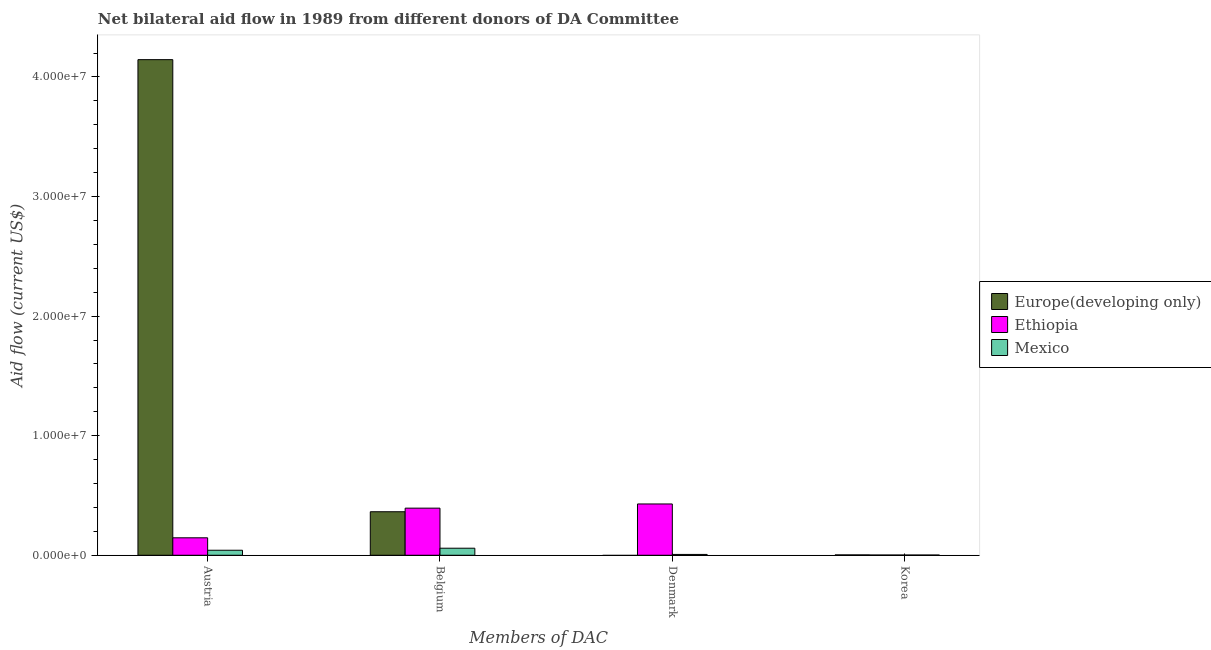How many different coloured bars are there?
Your answer should be compact. 3. How many groups of bars are there?
Make the answer very short. 4. Are the number of bars on each tick of the X-axis equal?
Make the answer very short. No. How many bars are there on the 1st tick from the right?
Keep it short and to the point. 3. What is the label of the 1st group of bars from the left?
Your response must be concise. Austria. Across all countries, what is the maximum amount of aid given by korea?
Ensure brevity in your answer.  3.00e+04. Across all countries, what is the minimum amount of aid given by belgium?
Your answer should be very brief. 5.90e+05. In which country was the amount of aid given by belgium maximum?
Keep it short and to the point. Ethiopia. What is the total amount of aid given by korea in the graph?
Your answer should be compact. 7.00e+04. What is the difference between the amount of aid given by austria in Ethiopia and that in Mexico?
Ensure brevity in your answer.  1.04e+06. What is the difference between the amount of aid given by austria in Mexico and the amount of aid given by denmark in Ethiopia?
Your response must be concise. -3.87e+06. What is the average amount of aid given by belgium per country?
Provide a short and direct response. 2.72e+06. What is the difference between the amount of aid given by austria and amount of aid given by belgium in Mexico?
Make the answer very short. -1.70e+05. In how many countries, is the amount of aid given by austria greater than 36000000 US$?
Your answer should be very brief. 1. What is the ratio of the amount of aid given by belgium in Ethiopia to that in Europe(developing only)?
Offer a terse response. 1.08. Is the amount of aid given by belgium in Mexico less than that in Ethiopia?
Your answer should be compact. Yes. Is the difference between the amount of aid given by korea in Mexico and Ethiopia greater than the difference between the amount of aid given by austria in Mexico and Ethiopia?
Your answer should be compact. Yes. What is the difference between the highest and the lowest amount of aid given by denmark?
Provide a succinct answer. 4.29e+06. In how many countries, is the amount of aid given by austria greater than the average amount of aid given by austria taken over all countries?
Your answer should be very brief. 1. Is it the case that in every country, the sum of the amount of aid given by austria and amount of aid given by korea is greater than the sum of amount of aid given by belgium and amount of aid given by denmark?
Offer a terse response. No. Is it the case that in every country, the sum of the amount of aid given by austria and amount of aid given by belgium is greater than the amount of aid given by denmark?
Offer a terse response. Yes. Are all the bars in the graph horizontal?
Keep it short and to the point. No. What is the difference between two consecutive major ticks on the Y-axis?
Provide a succinct answer. 1.00e+07. Does the graph contain any zero values?
Provide a succinct answer. Yes. Does the graph contain grids?
Your answer should be very brief. No. Where does the legend appear in the graph?
Provide a short and direct response. Center right. How are the legend labels stacked?
Your response must be concise. Vertical. What is the title of the graph?
Keep it short and to the point. Net bilateral aid flow in 1989 from different donors of DA Committee. Does "Greece" appear as one of the legend labels in the graph?
Keep it short and to the point. No. What is the label or title of the X-axis?
Give a very brief answer. Members of DAC. What is the label or title of the Y-axis?
Your answer should be very brief. Aid flow (current US$). What is the Aid flow (current US$) in Europe(developing only) in Austria?
Provide a succinct answer. 4.14e+07. What is the Aid flow (current US$) in Ethiopia in Austria?
Your response must be concise. 1.46e+06. What is the Aid flow (current US$) in Europe(developing only) in Belgium?
Your response must be concise. 3.64e+06. What is the Aid flow (current US$) of Ethiopia in Belgium?
Give a very brief answer. 3.94e+06. What is the Aid flow (current US$) of Mexico in Belgium?
Your answer should be very brief. 5.90e+05. What is the Aid flow (current US$) in Ethiopia in Denmark?
Provide a succinct answer. 4.29e+06. What is the Aid flow (current US$) of Mexico in Denmark?
Keep it short and to the point. 7.00e+04. What is the Aid flow (current US$) in Ethiopia in Korea?
Make the answer very short. 2.00e+04. Across all Members of DAC, what is the maximum Aid flow (current US$) in Europe(developing only)?
Offer a terse response. 4.14e+07. Across all Members of DAC, what is the maximum Aid flow (current US$) in Ethiopia?
Provide a succinct answer. 4.29e+06. Across all Members of DAC, what is the maximum Aid flow (current US$) of Mexico?
Your answer should be very brief. 5.90e+05. Across all Members of DAC, what is the minimum Aid flow (current US$) of Europe(developing only)?
Make the answer very short. 0. What is the total Aid flow (current US$) in Europe(developing only) in the graph?
Make the answer very short. 4.51e+07. What is the total Aid flow (current US$) in Ethiopia in the graph?
Give a very brief answer. 9.71e+06. What is the total Aid flow (current US$) of Mexico in the graph?
Provide a short and direct response. 1.10e+06. What is the difference between the Aid flow (current US$) of Europe(developing only) in Austria and that in Belgium?
Your response must be concise. 3.78e+07. What is the difference between the Aid flow (current US$) in Ethiopia in Austria and that in Belgium?
Your answer should be very brief. -2.48e+06. What is the difference between the Aid flow (current US$) of Mexico in Austria and that in Belgium?
Make the answer very short. -1.70e+05. What is the difference between the Aid flow (current US$) of Ethiopia in Austria and that in Denmark?
Ensure brevity in your answer.  -2.83e+06. What is the difference between the Aid flow (current US$) in Mexico in Austria and that in Denmark?
Ensure brevity in your answer.  3.50e+05. What is the difference between the Aid flow (current US$) of Europe(developing only) in Austria and that in Korea?
Provide a succinct answer. 4.14e+07. What is the difference between the Aid flow (current US$) of Ethiopia in Austria and that in Korea?
Your answer should be very brief. 1.44e+06. What is the difference between the Aid flow (current US$) of Ethiopia in Belgium and that in Denmark?
Your answer should be very brief. -3.50e+05. What is the difference between the Aid flow (current US$) in Mexico in Belgium and that in Denmark?
Keep it short and to the point. 5.20e+05. What is the difference between the Aid flow (current US$) of Europe(developing only) in Belgium and that in Korea?
Provide a short and direct response. 3.61e+06. What is the difference between the Aid flow (current US$) in Ethiopia in Belgium and that in Korea?
Your answer should be compact. 3.92e+06. What is the difference between the Aid flow (current US$) of Mexico in Belgium and that in Korea?
Your response must be concise. 5.70e+05. What is the difference between the Aid flow (current US$) of Ethiopia in Denmark and that in Korea?
Keep it short and to the point. 4.27e+06. What is the difference between the Aid flow (current US$) of Europe(developing only) in Austria and the Aid flow (current US$) of Ethiopia in Belgium?
Your response must be concise. 3.75e+07. What is the difference between the Aid flow (current US$) in Europe(developing only) in Austria and the Aid flow (current US$) in Mexico in Belgium?
Your answer should be very brief. 4.09e+07. What is the difference between the Aid flow (current US$) in Ethiopia in Austria and the Aid flow (current US$) in Mexico in Belgium?
Provide a succinct answer. 8.70e+05. What is the difference between the Aid flow (current US$) in Europe(developing only) in Austria and the Aid flow (current US$) in Ethiopia in Denmark?
Make the answer very short. 3.72e+07. What is the difference between the Aid flow (current US$) of Europe(developing only) in Austria and the Aid flow (current US$) of Mexico in Denmark?
Ensure brevity in your answer.  4.14e+07. What is the difference between the Aid flow (current US$) of Ethiopia in Austria and the Aid flow (current US$) of Mexico in Denmark?
Your answer should be compact. 1.39e+06. What is the difference between the Aid flow (current US$) of Europe(developing only) in Austria and the Aid flow (current US$) of Ethiopia in Korea?
Your response must be concise. 4.14e+07. What is the difference between the Aid flow (current US$) of Europe(developing only) in Austria and the Aid flow (current US$) of Mexico in Korea?
Give a very brief answer. 4.14e+07. What is the difference between the Aid flow (current US$) in Ethiopia in Austria and the Aid flow (current US$) in Mexico in Korea?
Keep it short and to the point. 1.44e+06. What is the difference between the Aid flow (current US$) in Europe(developing only) in Belgium and the Aid flow (current US$) in Ethiopia in Denmark?
Your answer should be very brief. -6.50e+05. What is the difference between the Aid flow (current US$) of Europe(developing only) in Belgium and the Aid flow (current US$) of Mexico in Denmark?
Your answer should be compact. 3.57e+06. What is the difference between the Aid flow (current US$) of Ethiopia in Belgium and the Aid flow (current US$) of Mexico in Denmark?
Give a very brief answer. 3.87e+06. What is the difference between the Aid flow (current US$) in Europe(developing only) in Belgium and the Aid flow (current US$) in Ethiopia in Korea?
Your answer should be compact. 3.62e+06. What is the difference between the Aid flow (current US$) in Europe(developing only) in Belgium and the Aid flow (current US$) in Mexico in Korea?
Make the answer very short. 3.62e+06. What is the difference between the Aid flow (current US$) in Ethiopia in Belgium and the Aid flow (current US$) in Mexico in Korea?
Offer a very short reply. 3.92e+06. What is the difference between the Aid flow (current US$) of Ethiopia in Denmark and the Aid flow (current US$) of Mexico in Korea?
Provide a succinct answer. 4.27e+06. What is the average Aid flow (current US$) of Europe(developing only) per Members of DAC?
Provide a short and direct response. 1.13e+07. What is the average Aid flow (current US$) of Ethiopia per Members of DAC?
Your answer should be very brief. 2.43e+06. What is the average Aid flow (current US$) in Mexico per Members of DAC?
Provide a succinct answer. 2.75e+05. What is the difference between the Aid flow (current US$) of Europe(developing only) and Aid flow (current US$) of Ethiopia in Austria?
Make the answer very short. 4.00e+07. What is the difference between the Aid flow (current US$) of Europe(developing only) and Aid flow (current US$) of Mexico in Austria?
Your answer should be very brief. 4.10e+07. What is the difference between the Aid flow (current US$) of Ethiopia and Aid flow (current US$) of Mexico in Austria?
Your response must be concise. 1.04e+06. What is the difference between the Aid flow (current US$) in Europe(developing only) and Aid flow (current US$) in Mexico in Belgium?
Keep it short and to the point. 3.05e+06. What is the difference between the Aid flow (current US$) in Ethiopia and Aid flow (current US$) in Mexico in Belgium?
Provide a succinct answer. 3.35e+06. What is the difference between the Aid flow (current US$) in Ethiopia and Aid flow (current US$) in Mexico in Denmark?
Your response must be concise. 4.22e+06. What is the ratio of the Aid flow (current US$) in Europe(developing only) in Austria to that in Belgium?
Make the answer very short. 11.39. What is the ratio of the Aid flow (current US$) in Ethiopia in Austria to that in Belgium?
Provide a short and direct response. 0.37. What is the ratio of the Aid flow (current US$) of Mexico in Austria to that in Belgium?
Your answer should be very brief. 0.71. What is the ratio of the Aid flow (current US$) of Ethiopia in Austria to that in Denmark?
Make the answer very short. 0.34. What is the ratio of the Aid flow (current US$) of Europe(developing only) in Austria to that in Korea?
Offer a very short reply. 1381.67. What is the ratio of the Aid flow (current US$) in Ethiopia in Austria to that in Korea?
Make the answer very short. 73. What is the ratio of the Aid flow (current US$) in Ethiopia in Belgium to that in Denmark?
Ensure brevity in your answer.  0.92. What is the ratio of the Aid flow (current US$) of Mexico in Belgium to that in Denmark?
Provide a succinct answer. 8.43. What is the ratio of the Aid flow (current US$) of Europe(developing only) in Belgium to that in Korea?
Keep it short and to the point. 121.33. What is the ratio of the Aid flow (current US$) of Ethiopia in Belgium to that in Korea?
Give a very brief answer. 197. What is the ratio of the Aid flow (current US$) in Mexico in Belgium to that in Korea?
Offer a terse response. 29.5. What is the ratio of the Aid flow (current US$) in Ethiopia in Denmark to that in Korea?
Ensure brevity in your answer.  214.5. What is the difference between the highest and the second highest Aid flow (current US$) of Europe(developing only)?
Provide a short and direct response. 3.78e+07. What is the difference between the highest and the lowest Aid flow (current US$) in Europe(developing only)?
Give a very brief answer. 4.14e+07. What is the difference between the highest and the lowest Aid flow (current US$) of Ethiopia?
Make the answer very short. 4.27e+06. What is the difference between the highest and the lowest Aid flow (current US$) of Mexico?
Your response must be concise. 5.70e+05. 